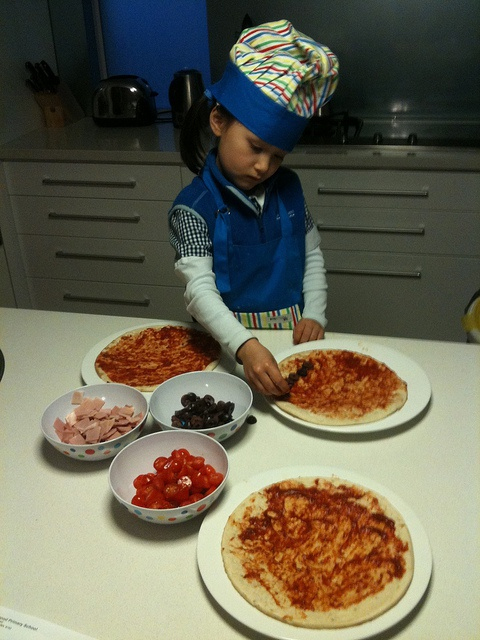Describe the objects in this image and their specific colors. I can see dining table in black, beige, darkgray, and gray tones, people in black, navy, darkgray, and gray tones, pizza in black, brown, maroon, and tan tones, bowl in black, darkgray, maroon, and gray tones, and pizza in black, brown, maroon, and tan tones in this image. 